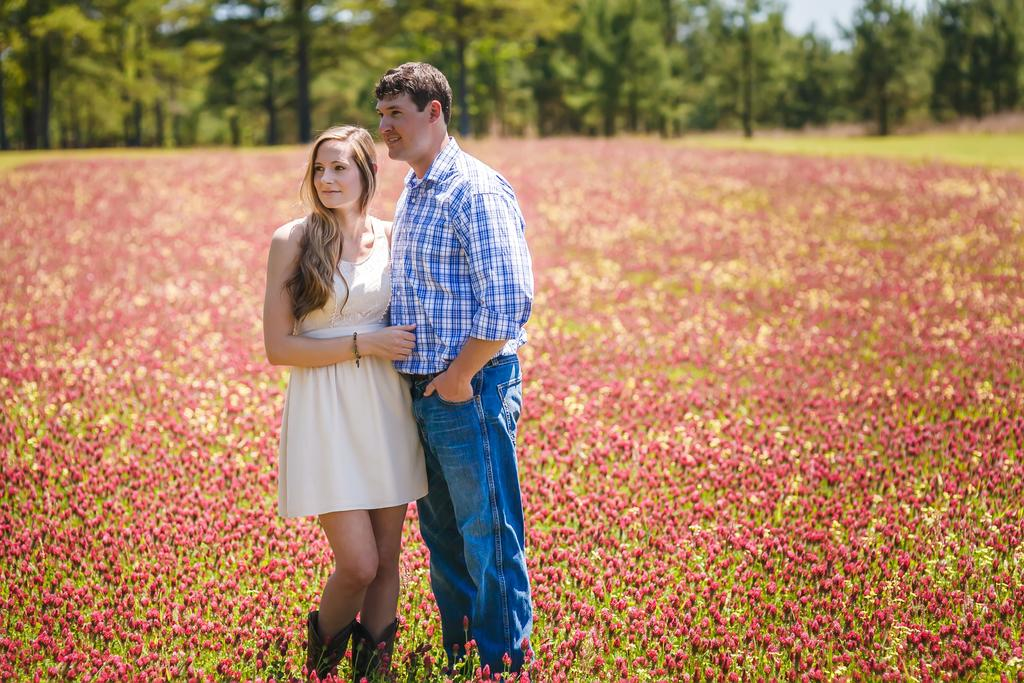Who are the people in the foreground of the image? There is a man and a woman in the foreground of the image. What are the man and woman doing in the image? Both the man and woman are standing. What can be seen in the background of the image? There are flowers, plants, and trees in the background of the image. How many fairies are flying around the flowers in the image? There are no fairies present in the image; it only features a man, a woman, and the natural background. 